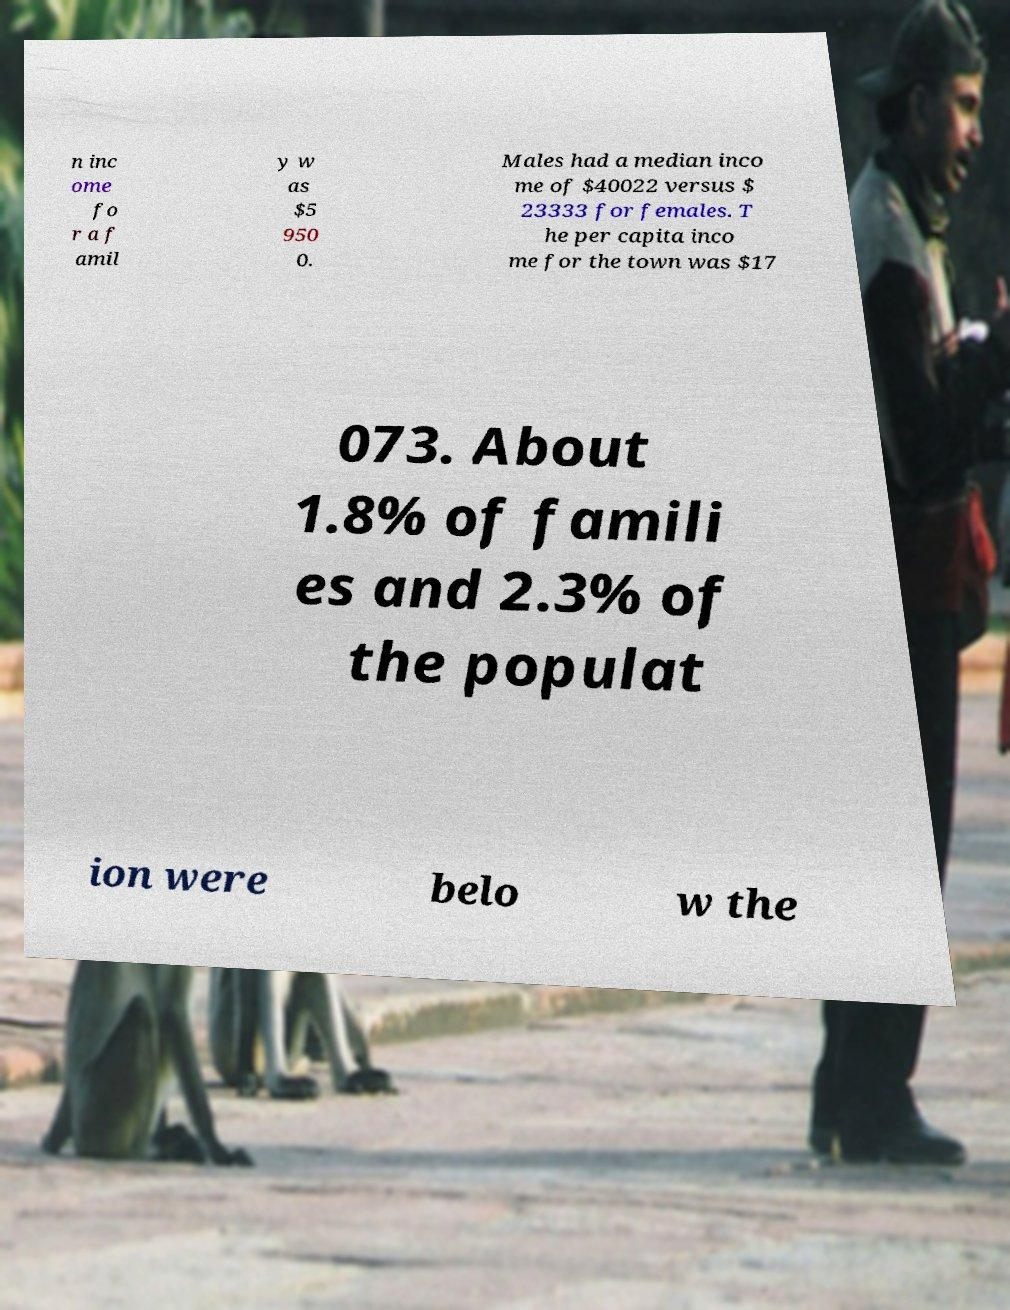Can you read and provide the text displayed in the image?This photo seems to have some interesting text. Can you extract and type it out for me? n inc ome fo r a f amil y w as $5 950 0. Males had a median inco me of $40022 versus $ 23333 for females. T he per capita inco me for the town was $17 073. About 1.8% of famili es and 2.3% of the populat ion were belo w the 